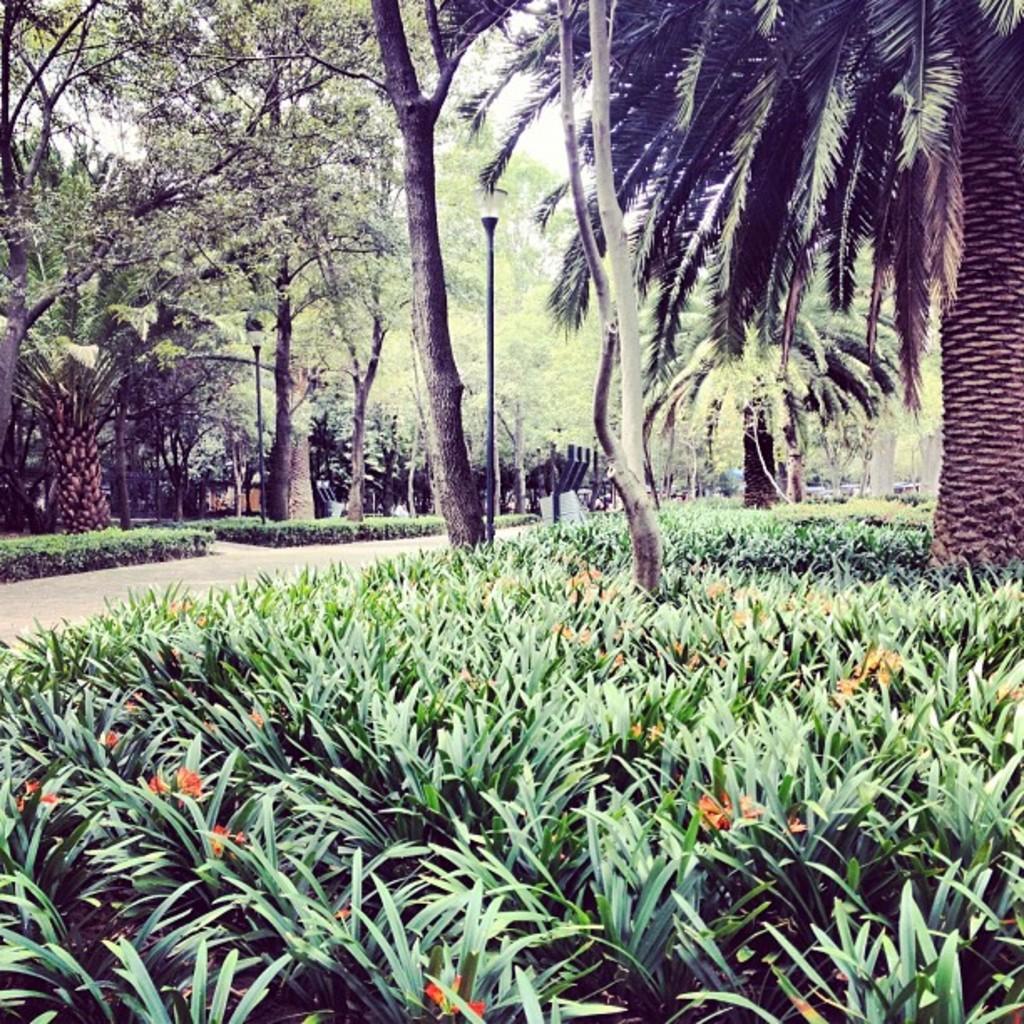Describe this image in one or two sentences. In the image it seems like a park, there are flower plants and trees in the picture. 